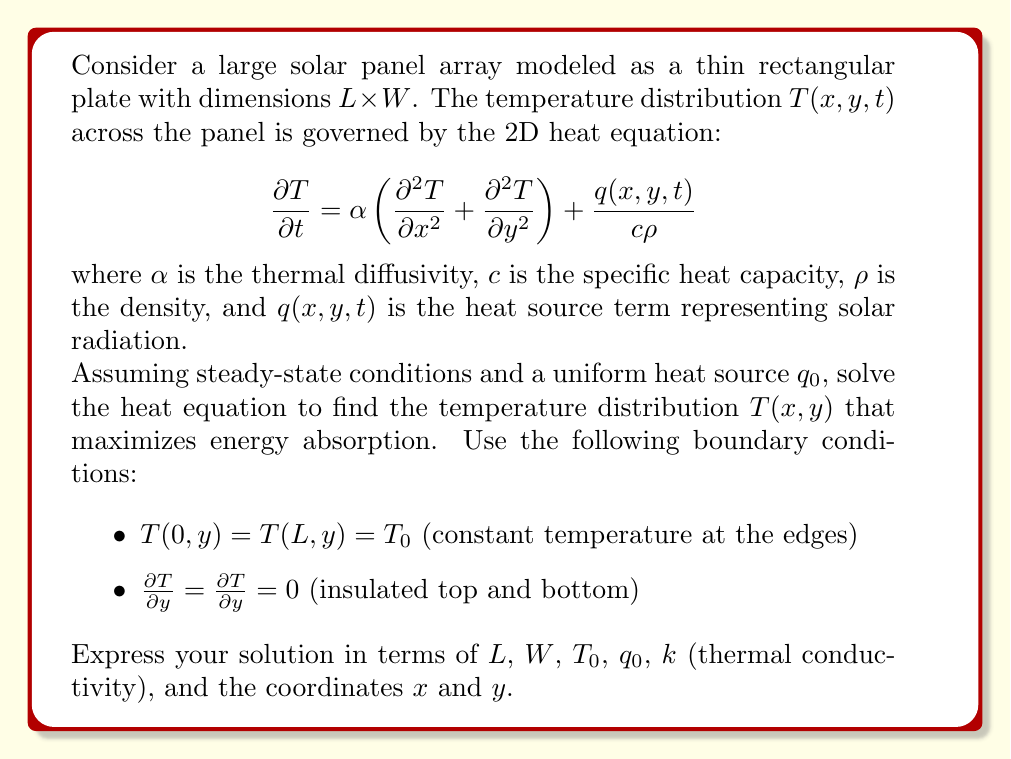Help me with this question. To solve this problem, we'll follow these steps:

1) First, we simplify the heat equation for steady-state conditions:
   $$\alpha \left(\frac{\partial^2 T}{\partial x^2} + \frac{\partial^2 T}{\partial y^2}\right) + \frac{q_0}{c\rho} = 0$$

2) We can rewrite this using the thermal conductivity $k = \alpha c\rho$:
   $$k\left(\frac{\partial^2 T}{\partial x^2} + \frac{\partial^2 T}{\partial y^2}\right) + q_0 = 0$$

3) Let's separate the solution into two parts: $T(x,y) = u(x,y) + v(x)$
   where $u(x,y)$ satisfies the homogeneous equation and $v(x)$ accounts for the heat source.

4) For $v(x)$, we solve:
   $$k\frac{d^2v}{dx^2} + q_0 = 0$$
   $$v(x) = -\frac{q_0}{2k}x^2 + Ax + B$$
   Using the boundary conditions $v(0) = v(L) = 0$, we get:
   $$v(x) = \frac{q_0}{2k}x(L-x)$$

5) For $u(x,y)$, we solve:
   $$\frac{\partial^2 u}{\partial x^2} + \frac{\partial^2 u}{\partial y^2} = 0$$
   Using separation of variables $u(x,y) = X(x)Y(y)$, we get:
   $$X''Y + XY'' = 0$$
   $$\frac{X''}{X} = -\frac{Y''}{Y} = -\lambda^2$$

6) Solving for $X$ and $Y$ with the given boundary conditions:
   $$X(x) = A\cos(\lambda x) + B\sin(\lambda x)$$
   $$Y(y) = C\cosh(\lambda y) + D\sinh(\lambda y)$$
   The boundary conditions for $y$ give $D = 0$ and $\lambda = \frac{n\pi}{L}$ for $n = 0, 1, 2, ...$

7) The general solution is:
   $$u(x,y) = \sum_{n=0}^{\infty} (A_n\cos(\frac{n\pi x}{L}) + B_n\sin(\frac{n\pi x}{L}))\cosh(\frac{n\pi y}{L})$$

8) Applying the boundary conditions for $x$:
   $$T(0,y) = T(L,y) = T_0$$
   This gives $A_n = 0$ for $n \geq 1$ and $A_0 = T_0$

9) The final solution is:
   $$T(x,y) = T_0 + \frac{q_0}{2k}x(L-x)$$

This solution maximizes energy absorption by allowing the temperature to rise in the center of the panel while maintaining the edge temperatures.
Answer: $$T(x,y) = T_0 + \frac{q_0}{2k}x(L-x)$$ 